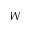Convert formula to latex. <formula><loc_0><loc_0><loc_500><loc_500>W</formula> 